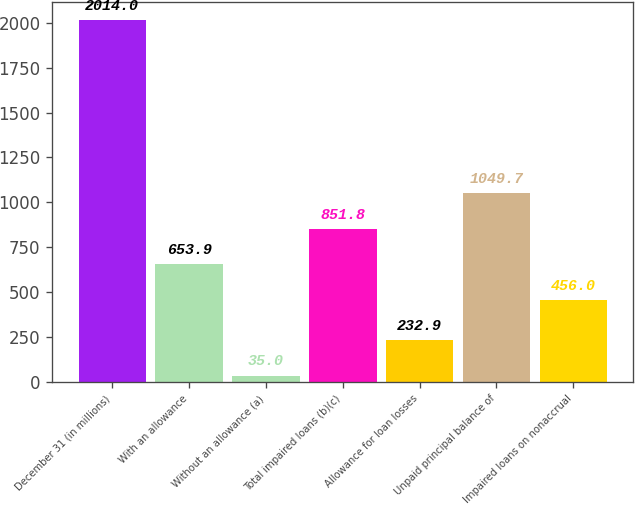Convert chart. <chart><loc_0><loc_0><loc_500><loc_500><bar_chart><fcel>December 31 (in millions)<fcel>With an allowance<fcel>Without an allowance (a)<fcel>Total impaired loans (b)(c)<fcel>Allowance for loan losses<fcel>Unpaid principal balance of<fcel>Impaired loans on nonaccrual<nl><fcel>2014<fcel>653.9<fcel>35<fcel>851.8<fcel>232.9<fcel>1049.7<fcel>456<nl></chart> 